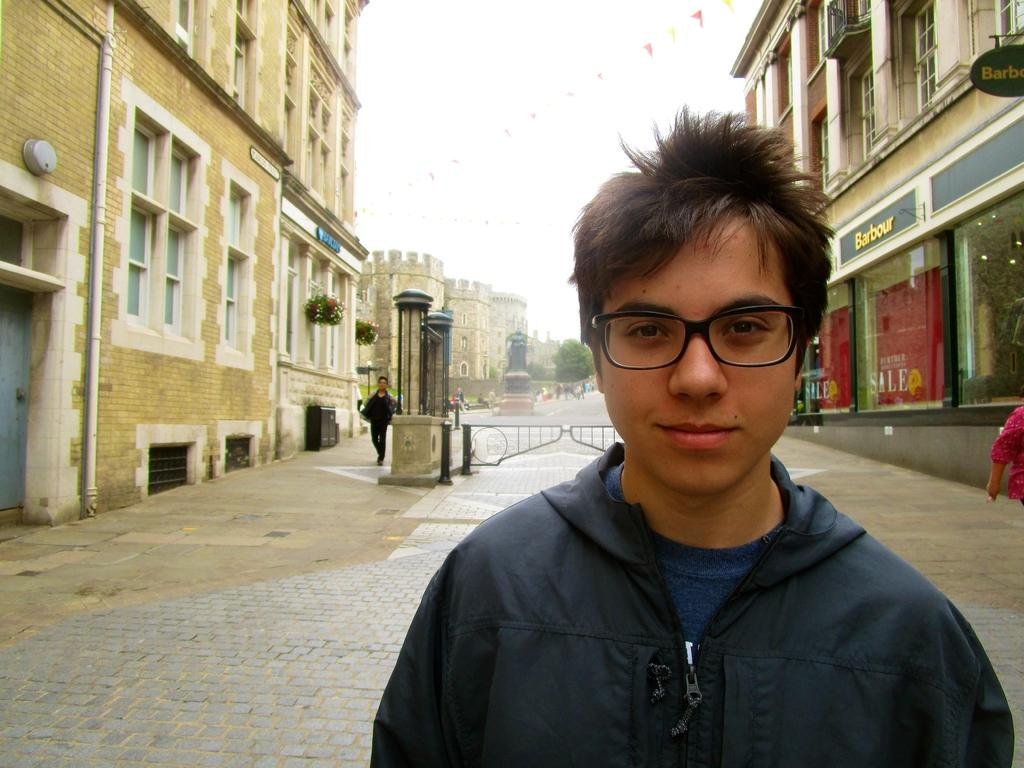What are the people in the image doing? The persons in the image are walking on the road. What can be seen in the background of the image? There are buildings, pipelines, doors, pillars, stores, the sky, and houseplants visible in the background. Can you tell me how many cables are hanging from the bed in the image? There is no bed present in the image, so it is not possible to determine the number of cables hanging from it. 